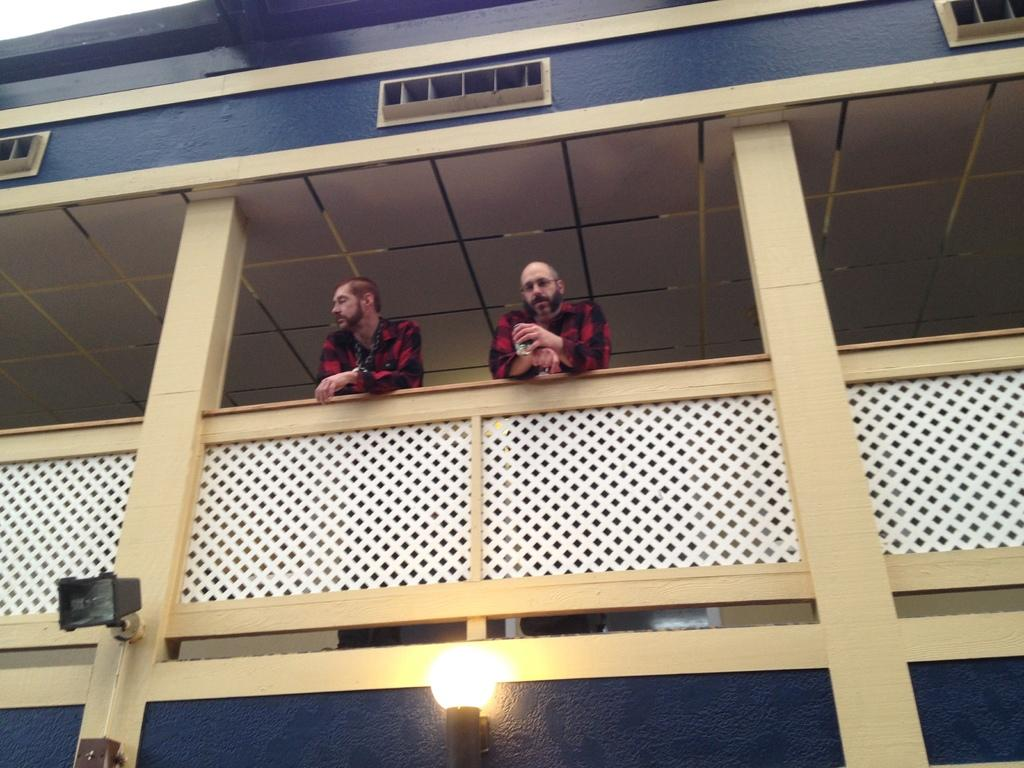How many people are visible in the image? There are two men standing in the balcony. What are the men doing in the image? The men are standing in the balcony. What can be seen at the bottom of the image? There are two lights attached to the wall of a building at the bottom of the image. What type of snail can be seen crawling on the face of one of the men in the image? There is no snail or face visible in the image; it only features two men standing in the balcony and two lights at the bottom. 